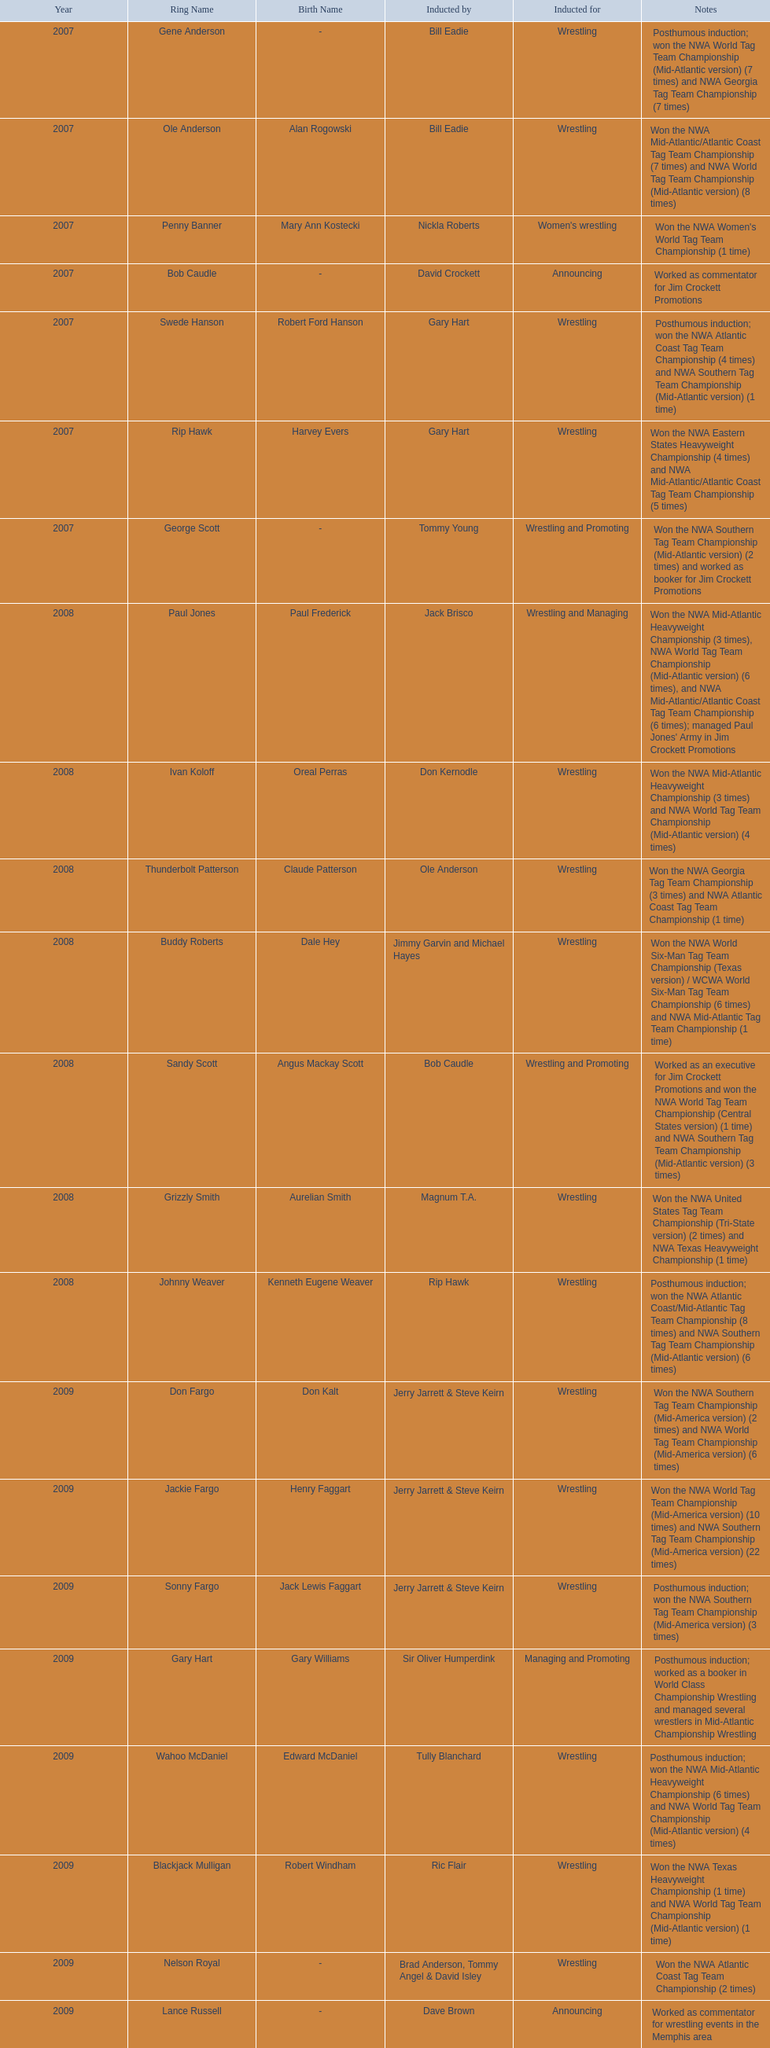What were the names of the inductees in 2007? Gene Anderson, Ole Anderson\n(Alan Rogowski), Penny Banner\n(Mary Ann Kostecki), Bob Caudle, Swede Hanson\n(Robert Ford Hanson), Rip Hawk\n(Harvey Evers), George Scott. Of the 2007 inductees, which were posthumous? Gene Anderson, Swede Hanson\n(Robert Ford Hanson). Besides swede hanson, what other 2007 inductee was not living at the time of induction? Gene Anderson. 